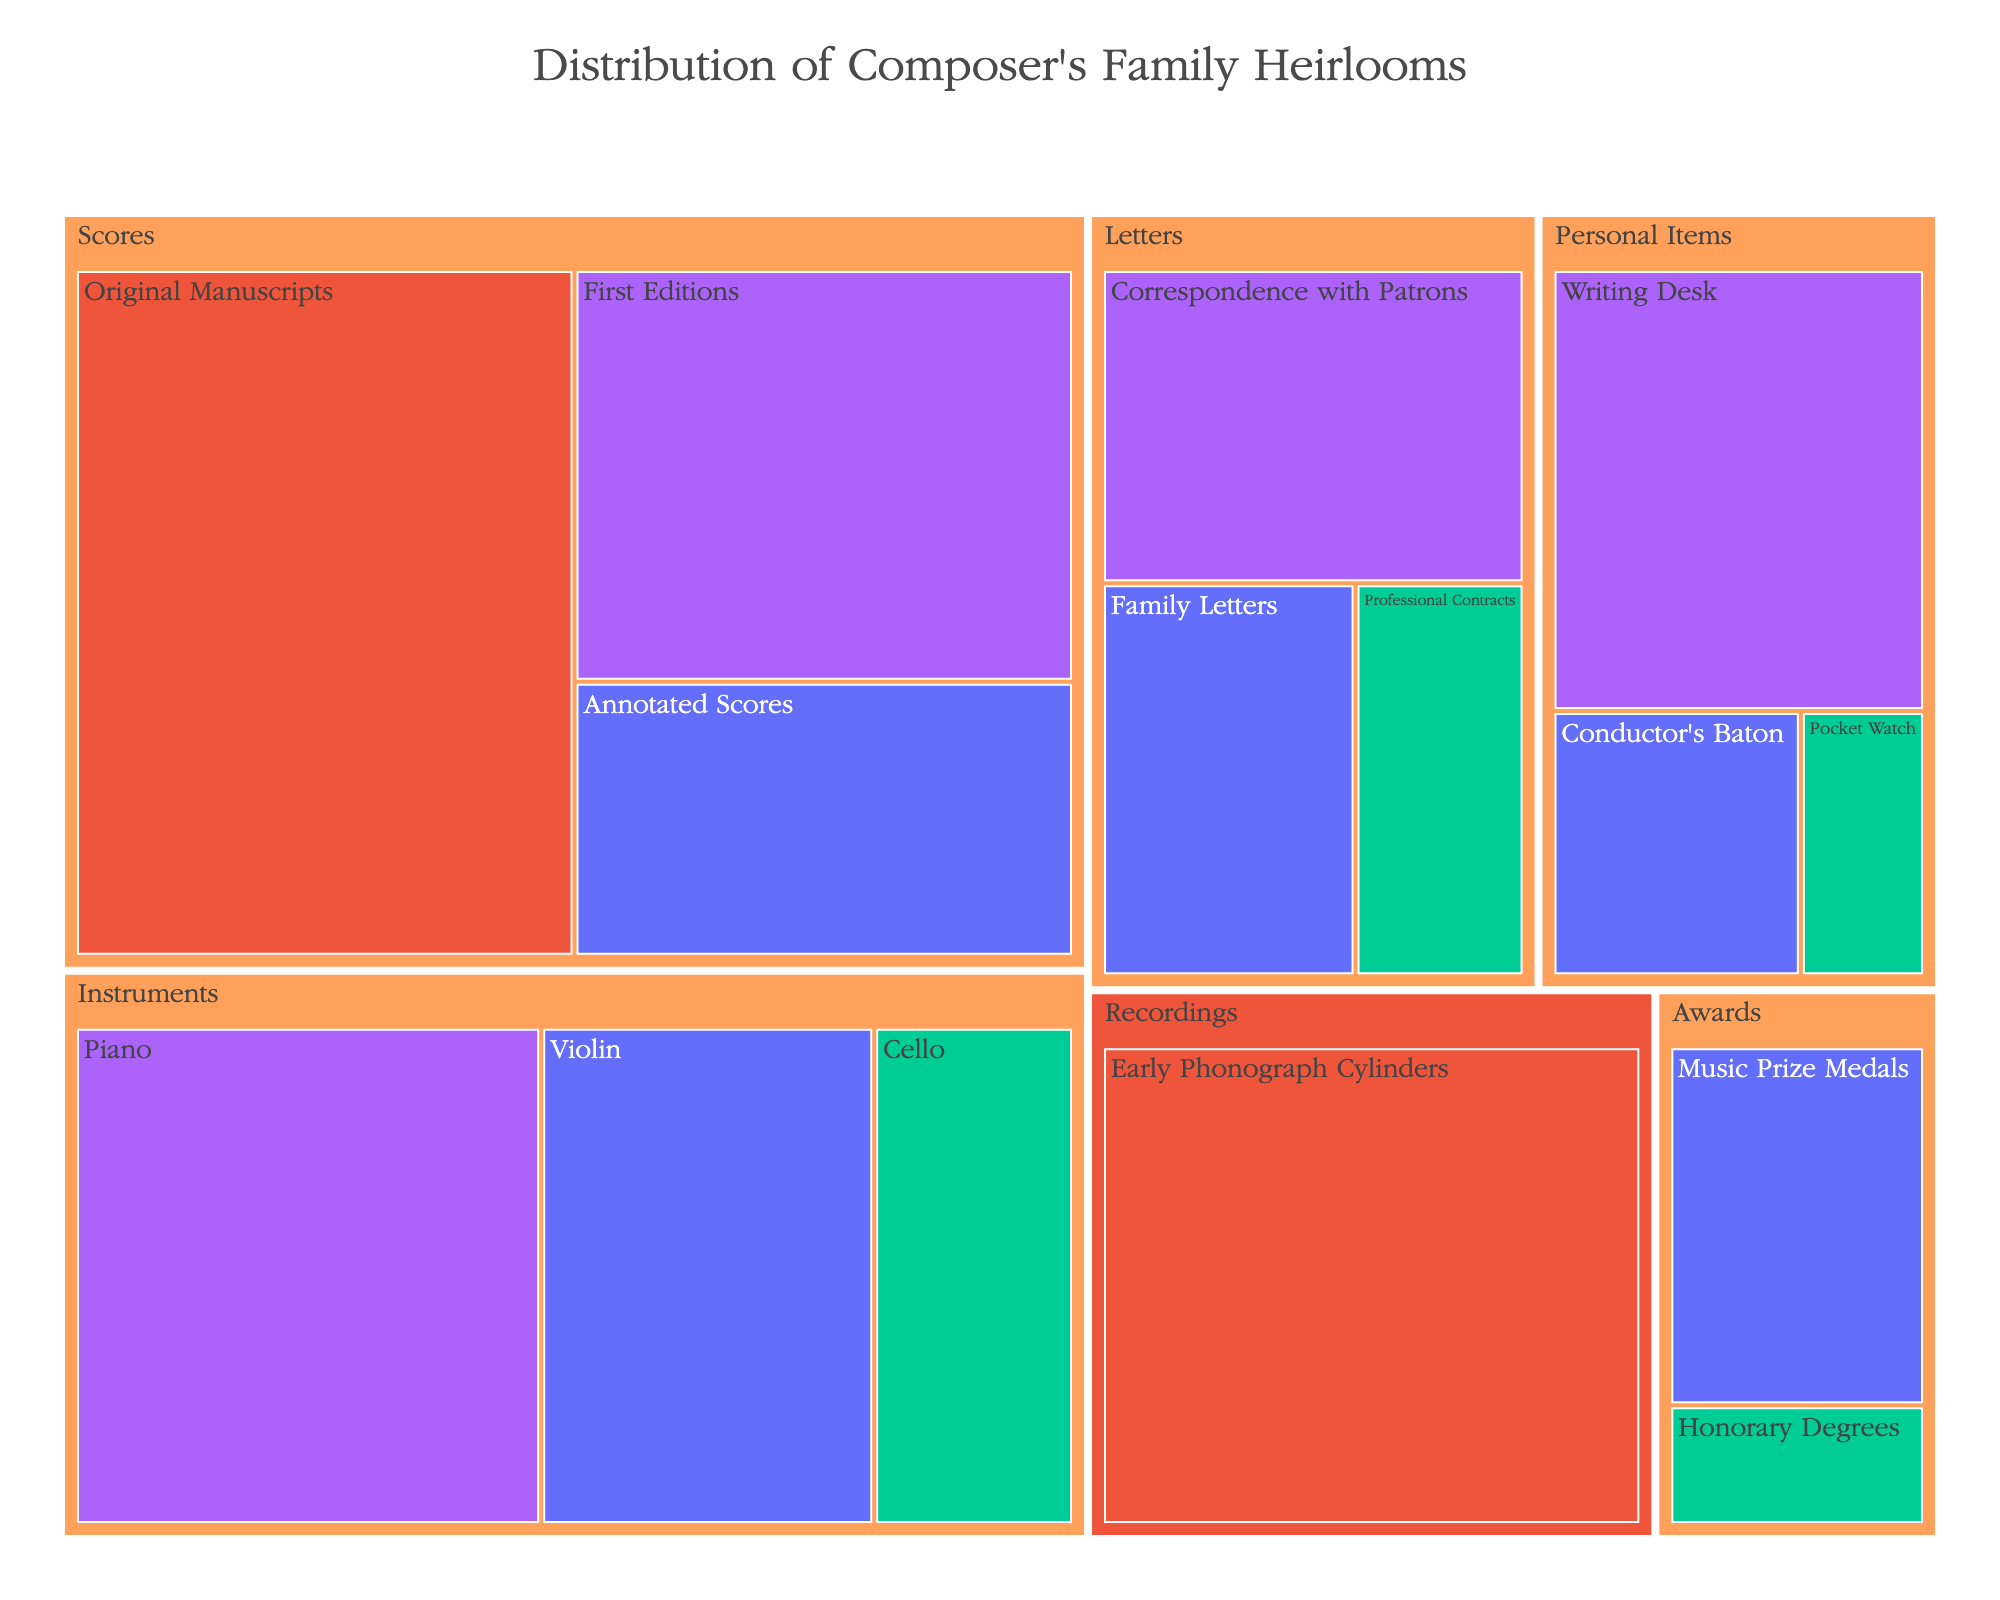What is the title of the treemap? The title is prominently displayed at the top of the figure.
Answer: Distribution of Composer's Family Heirlooms Which category has the highest total value? By comparing the sizes of the blocks, we see which category occupies the most space.
Answer: Scores What is the age of the oldest family heirloom? Information is given in the hover data; by hovering over each block, we find the oldest age.
Answer: 200 years How many heirlooms are classified as having 'Very High' significance? By examining the color scale and locating blocks with 'Very High' significance, we count the number of such blocks.
Answer: 2 Which category contains the item with the lowest value? By looking at each category and identifying the smallest block, we find the category.
Answer: Personal Items What is the combined value of all items in the 'Letters' category? Sum the values of all items under the 'Letters' category.
Answer: 45 Which heirloom has the highest significance and what is its value? By looking for the 'Very High' significance block, we identify the heirloom and its value.
Answer: Original Manuscripts; 50 What is the average value of items within the 'Awards' category? Add the values of the items in the 'Awards' category and divide by the number of items.
Answer: (15 + 5) / 2 = 10 Compare the value and age of the oldest and newest 'Personal Items'. Find the respective blocks and compare their values and ages.
Answer: Oldest: Writing Desk, 170 years, 25 value; Newest: Conductor's Baton, 80 years, 10 value How many categories have items with a 'Low' significance? Count the categories containing items marked with 'Low' significance by their color in the treemap.
Answer: 4 